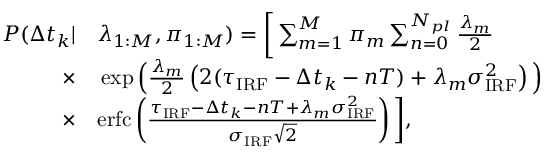Convert formula to latex. <formula><loc_0><loc_0><loc_500><loc_500>\begin{array} { r l } { P ( \Delta t _ { k } | } & \lambda _ { 1 \colon M } , \pi _ { 1 \colon M } ) = \left [ \sum _ { m = 1 } ^ { M } \pi _ { m } \sum _ { n = 0 } ^ { N _ { p l } } \frac { \lambda _ { m } } { 2 } } \\ { \times } & \exp \left ( \frac { \lambda _ { m } } { 2 } \left ( 2 ( \tau _ { I R F } - \Delta t _ { k } - n T ) + \lambda _ { m } \sigma _ { I R F } ^ { 2 } \right ) \right ) } \\ { \times } & e r f c \left ( \frac { \tau _ { I R F } - \Delta t _ { k } - n T + \lambda _ { m } \sigma _ { I R F } ^ { 2 } } { \sigma _ { I R F } \sqrt { 2 } } \right ) \right ] , } \end{array}</formula> 